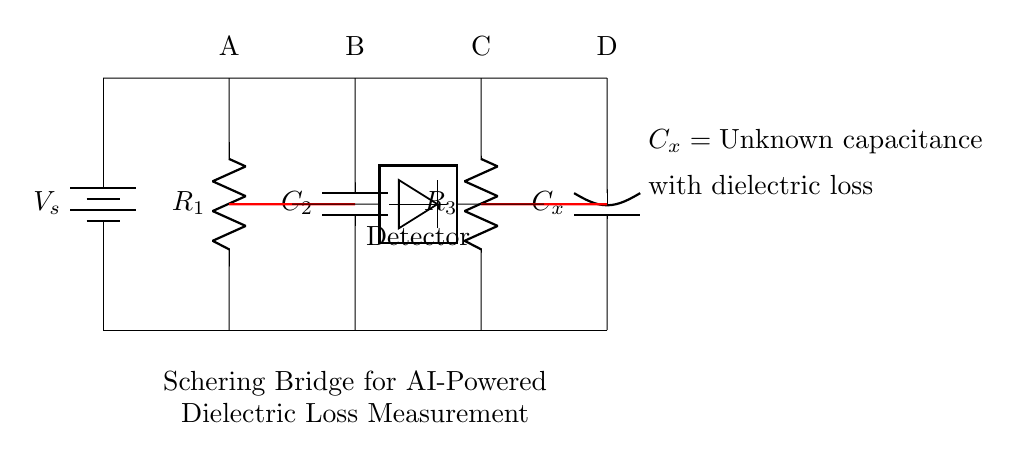What is the source voltage in this circuit? The source voltage, labeled as V_s, is indicated at the battery in the circuit. It represents the input voltage supplied to the Schering bridge.
Answer: V_s What type of component is C_x? C_x is labeled as an unknown capacitance with dielectric loss, indicating that it is a capacitive element whose value is not defined within this circuit diagram.
Answer: Capacitor What is the function of the detector in this bridge? The detector in the Schering bridge is used to measure the voltage difference between the nodes. It helps to assess the balance of the bridge and determine dielectric loss characteristics.
Answer: Measure voltage difference Which resistors are connected in series? Resistors R_1 and R_3 are connected in series from point A to point D, where the same current flows through both components.
Answer: R_1 and R_3 What is the significance of the short circuit connections shown in red? The red thick lines represent short circuits across the bridge, indicating that R_2 and R_4 (not shown in the circuit) are considered to facilitate the balance condition in the Schering bridge.
Answer: Balance condition Calculate the total impedance in the bridge if C_x is balanced. When balanced, the total impedance in the bridge equals the impedances of R_1 and R_3 combined with the reactance of C_x. The exact value would depend on the capacitance and resistance values, which are not provided in the diagram but typically leads to a specific measurement of dielectric loss.
Answer: Depends on values What is the primary application of the Schering bridge? The primary application of the Schering bridge is to measure the dielectric loss of insulating materials, which helps in evaluating the quality and performance of such materials in electrical applications.
Answer: Dielectric loss measurement 